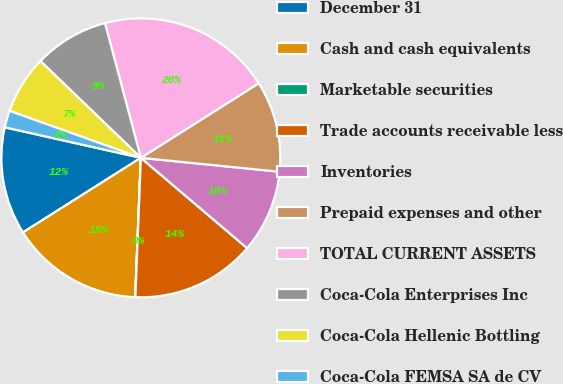Convert chart to OTSL. <chart><loc_0><loc_0><loc_500><loc_500><pie_chart><fcel>December 31<fcel>Cash and cash equivalents<fcel>Marketable securities<fcel>Trade accounts receivable less<fcel>Inventories<fcel>Prepaid expenses and other<fcel>TOTAL CURRENT ASSETS<fcel>Coca-Cola Enterprises Inc<fcel>Coca-Cola Hellenic Bottling<fcel>Coca-Cola FEMSA SA de CV<nl><fcel>12.49%<fcel>15.37%<fcel>0.03%<fcel>14.41%<fcel>9.62%<fcel>10.57%<fcel>20.16%<fcel>8.66%<fcel>6.74%<fcel>1.95%<nl></chart> 